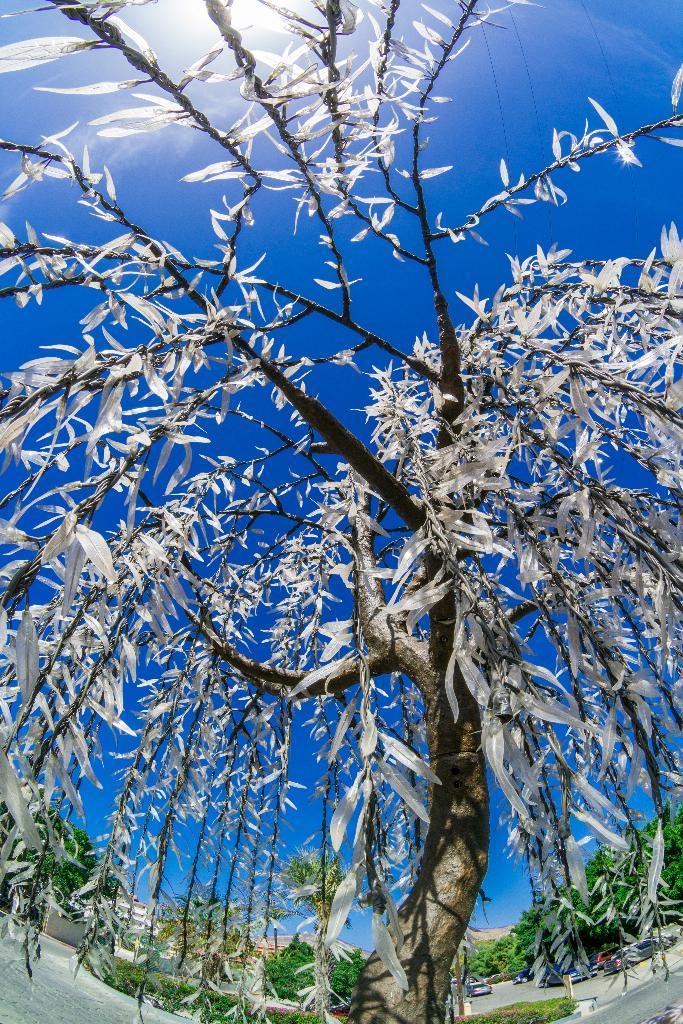Could you give a brief overview of what you see in this image? In this picture there is a tree in the center of the image. 